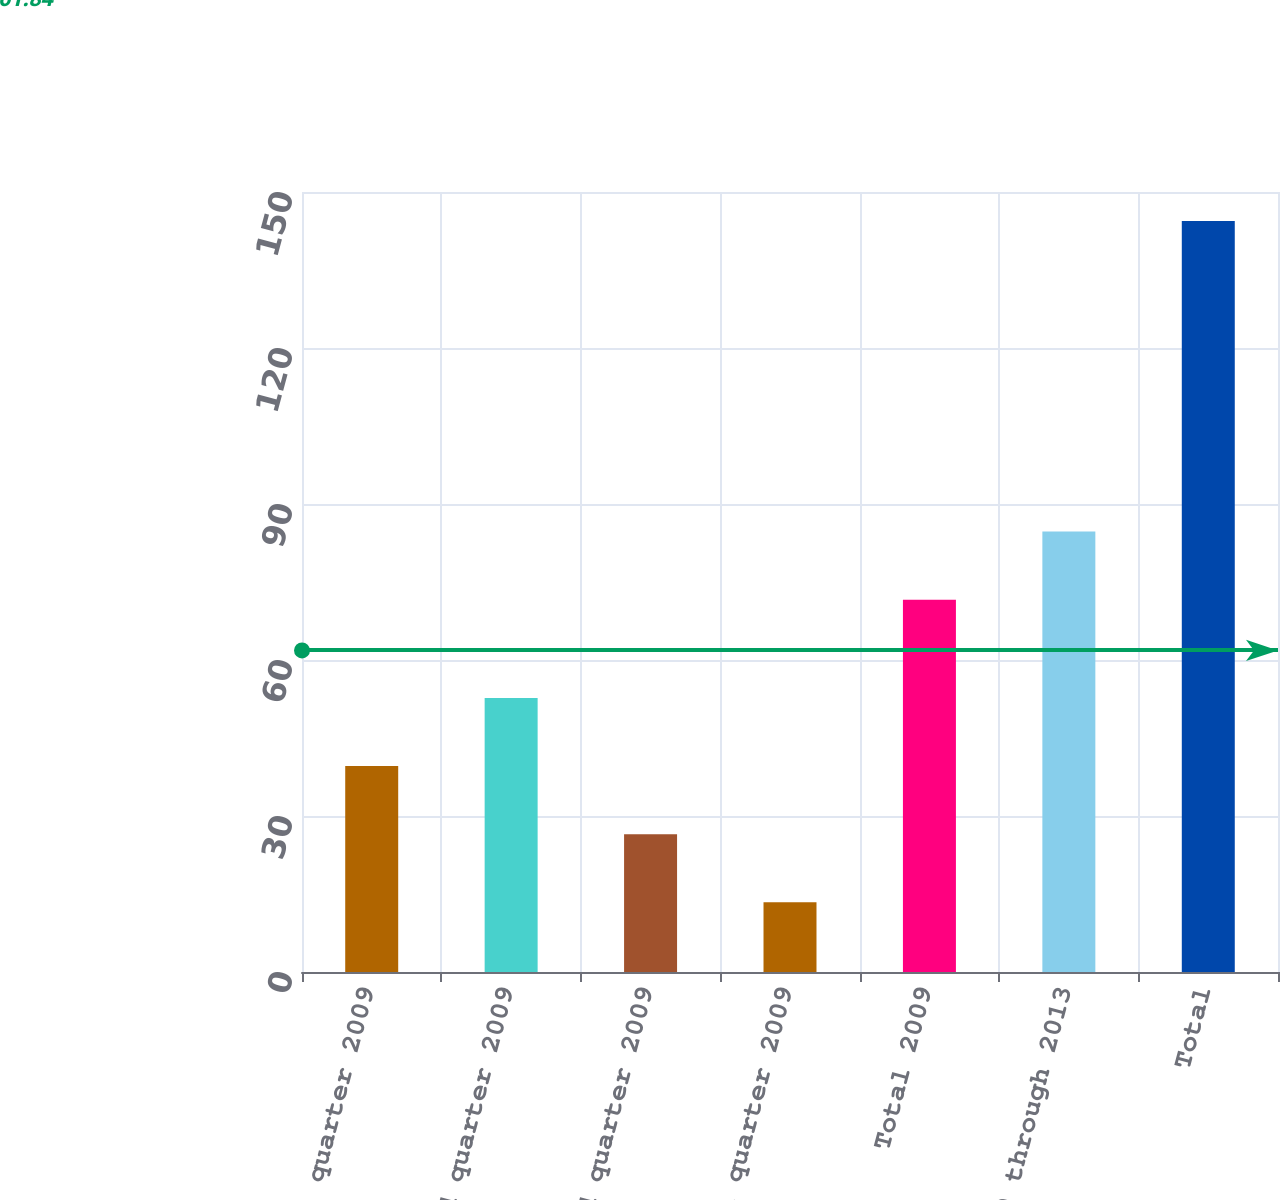<chart> <loc_0><loc_0><loc_500><loc_500><bar_chart><fcel>First quarter 2009<fcel>Second quarter 2009<fcel>Third quarter 2009<fcel>Fourth quarter 2009<fcel>Total 2009<fcel>2010 through 2013<fcel>Total<nl><fcel>39.6<fcel>52.7<fcel>26.5<fcel>13.4<fcel>71.6<fcel>84.7<fcel>144.4<nl></chart> 